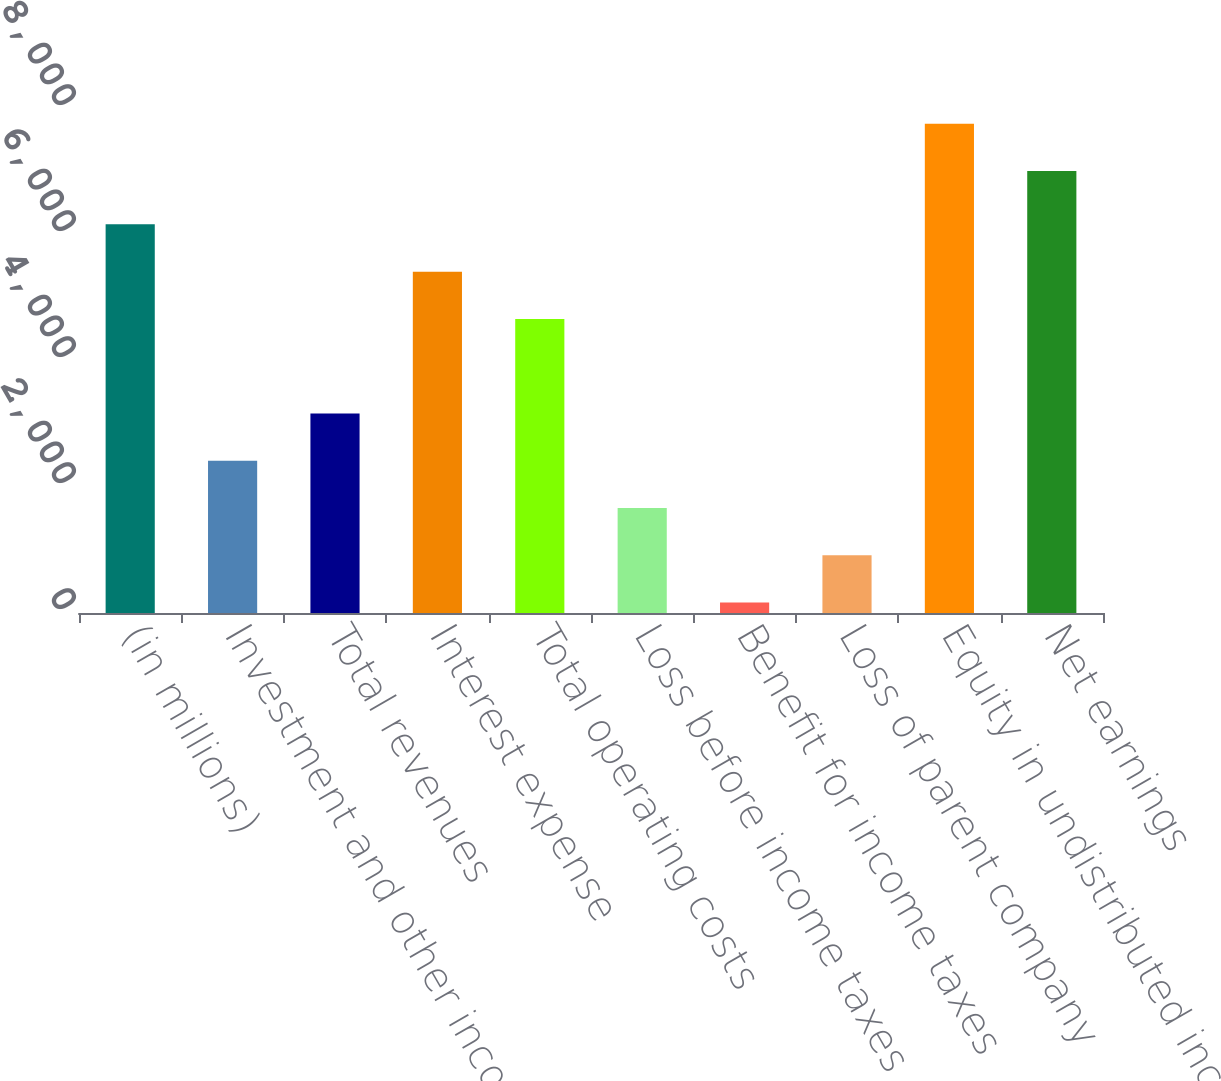Convert chart. <chart><loc_0><loc_0><loc_500><loc_500><bar_chart><fcel>(in millions)<fcel>Investment and other income<fcel>Total revenues<fcel>Interest expense<fcel>Total operating costs<fcel>Loss before income taxes<fcel>Benefit for income taxes<fcel>Loss of parent company<fcel>Equity in undistributed income<fcel>Net earnings<nl><fcel>6169<fcel>2416.5<fcel>3167<fcel>5418.5<fcel>4668<fcel>1666<fcel>165<fcel>915.5<fcel>7767.5<fcel>7017<nl></chart> 